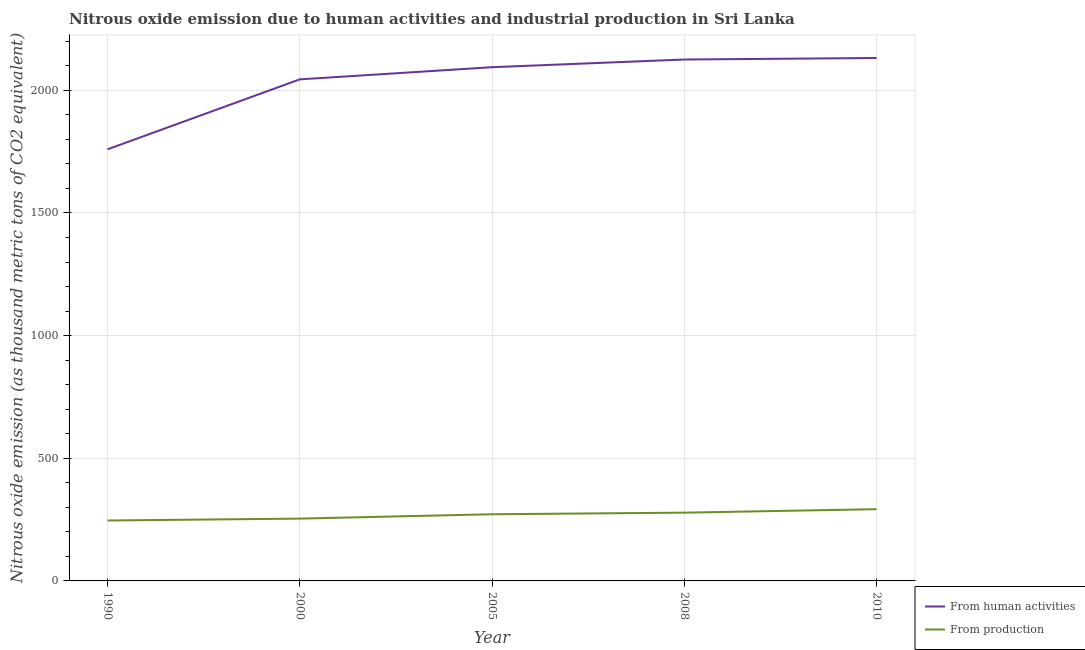Does the line corresponding to amount of emissions from human activities intersect with the line corresponding to amount of emissions generated from industries?
Give a very brief answer. No. What is the amount of emissions from human activities in 2010?
Your response must be concise. 2131.6. Across all years, what is the maximum amount of emissions generated from industries?
Keep it short and to the point. 292.4. Across all years, what is the minimum amount of emissions from human activities?
Keep it short and to the point. 1759.4. In which year was the amount of emissions generated from industries maximum?
Offer a terse response. 2010. In which year was the amount of emissions generated from industries minimum?
Your answer should be compact. 1990. What is the total amount of emissions from human activities in the graph?
Offer a very short reply. 1.02e+04. What is the difference between the amount of emissions from human activities in 1990 and that in 2005?
Your response must be concise. -334.7. What is the difference between the amount of emissions generated from industries in 2008 and the amount of emissions from human activities in 2005?
Provide a succinct answer. -1815.8. What is the average amount of emissions generated from industries per year?
Offer a terse response. 268.56. In the year 2005, what is the difference between the amount of emissions from human activities and amount of emissions generated from industries?
Ensure brevity in your answer.  1822.3. In how many years, is the amount of emissions from human activities greater than 1200 thousand metric tons?
Ensure brevity in your answer.  5. What is the ratio of the amount of emissions generated from industries in 2005 to that in 2010?
Your answer should be very brief. 0.93. Is the amount of emissions generated from industries in 2000 less than that in 2005?
Provide a short and direct response. Yes. What is the difference between the highest and the second highest amount of emissions from human activities?
Provide a short and direct response. 6.2. What is the difference between the highest and the lowest amount of emissions generated from industries?
Ensure brevity in your answer.  46.1. In how many years, is the amount of emissions from human activities greater than the average amount of emissions from human activities taken over all years?
Your response must be concise. 4. Is the sum of the amount of emissions from human activities in 1990 and 2010 greater than the maximum amount of emissions generated from industries across all years?
Provide a succinct answer. Yes. Does the amount of emissions from human activities monotonically increase over the years?
Provide a short and direct response. Yes. Is the amount of emissions from human activities strictly greater than the amount of emissions generated from industries over the years?
Your answer should be compact. Yes. Is the amount of emissions generated from industries strictly less than the amount of emissions from human activities over the years?
Offer a terse response. Yes. What is the difference between two consecutive major ticks on the Y-axis?
Provide a short and direct response. 500. Does the graph contain any zero values?
Your answer should be very brief. No. Where does the legend appear in the graph?
Your answer should be very brief. Bottom right. How are the legend labels stacked?
Give a very brief answer. Vertical. What is the title of the graph?
Offer a very short reply. Nitrous oxide emission due to human activities and industrial production in Sri Lanka. What is the label or title of the X-axis?
Your response must be concise. Year. What is the label or title of the Y-axis?
Make the answer very short. Nitrous oxide emission (as thousand metric tons of CO2 equivalent). What is the Nitrous oxide emission (as thousand metric tons of CO2 equivalent) in From human activities in 1990?
Provide a succinct answer. 1759.4. What is the Nitrous oxide emission (as thousand metric tons of CO2 equivalent) in From production in 1990?
Your answer should be very brief. 246.3. What is the Nitrous oxide emission (as thousand metric tons of CO2 equivalent) in From human activities in 2000?
Your response must be concise. 2044.5. What is the Nitrous oxide emission (as thousand metric tons of CO2 equivalent) in From production in 2000?
Your response must be concise. 254. What is the Nitrous oxide emission (as thousand metric tons of CO2 equivalent) of From human activities in 2005?
Your response must be concise. 2094.1. What is the Nitrous oxide emission (as thousand metric tons of CO2 equivalent) in From production in 2005?
Keep it short and to the point. 271.8. What is the Nitrous oxide emission (as thousand metric tons of CO2 equivalent) of From human activities in 2008?
Your response must be concise. 2125.4. What is the Nitrous oxide emission (as thousand metric tons of CO2 equivalent) in From production in 2008?
Provide a succinct answer. 278.3. What is the Nitrous oxide emission (as thousand metric tons of CO2 equivalent) of From human activities in 2010?
Provide a short and direct response. 2131.6. What is the Nitrous oxide emission (as thousand metric tons of CO2 equivalent) in From production in 2010?
Provide a short and direct response. 292.4. Across all years, what is the maximum Nitrous oxide emission (as thousand metric tons of CO2 equivalent) in From human activities?
Give a very brief answer. 2131.6. Across all years, what is the maximum Nitrous oxide emission (as thousand metric tons of CO2 equivalent) in From production?
Your response must be concise. 292.4. Across all years, what is the minimum Nitrous oxide emission (as thousand metric tons of CO2 equivalent) in From human activities?
Provide a succinct answer. 1759.4. Across all years, what is the minimum Nitrous oxide emission (as thousand metric tons of CO2 equivalent) of From production?
Offer a very short reply. 246.3. What is the total Nitrous oxide emission (as thousand metric tons of CO2 equivalent) of From human activities in the graph?
Your response must be concise. 1.02e+04. What is the total Nitrous oxide emission (as thousand metric tons of CO2 equivalent) of From production in the graph?
Offer a terse response. 1342.8. What is the difference between the Nitrous oxide emission (as thousand metric tons of CO2 equivalent) of From human activities in 1990 and that in 2000?
Ensure brevity in your answer.  -285.1. What is the difference between the Nitrous oxide emission (as thousand metric tons of CO2 equivalent) of From production in 1990 and that in 2000?
Ensure brevity in your answer.  -7.7. What is the difference between the Nitrous oxide emission (as thousand metric tons of CO2 equivalent) of From human activities in 1990 and that in 2005?
Provide a short and direct response. -334.7. What is the difference between the Nitrous oxide emission (as thousand metric tons of CO2 equivalent) of From production in 1990 and that in 2005?
Your answer should be very brief. -25.5. What is the difference between the Nitrous oxide emission (as thousand metric tons of CO2 equivalent) of From human activities in 1990 and that in 2008?
Give a very brief answer. -366. What is the difference between the Nitrous oxide emission (as thousand metric tons of CO2 equivalent) of From production in 1990 and that in 2008?
Provide a succinct answer. -32. What is the difference between the Nitrous oxide emission (as thousand metric tons of CO2 equivalent) of From human activities in 1990 and that in 2010?
Provide a succinct answer. -372.2. What is the difference between the Nitrous oxide emission (as thousand metric tons of CO2 equivalent) in From production in 1990 and that in 2010?
Offer a terse response. -46.1. What is the difference between the Nitrous oxide emission (as thousand metric tons of CO2 equivalent) of From human activities in 2000 and that in 2005?
Provide a short and direct response. -49.6. What is the difference between the Nitrous oxide emission (as thousand metric tons of CO2 equivalent) of From production in 2000 and that in 2005?
Offer a terse response. -17.8. What is the difference between the Nitrous oxide emission (as thousand metric tons of CO2 equivalent) of From human activities in 2000 and that in 2008?
Offer a terse response. -80.9. What is the difference between the Nitrous oxide emission (as thousand metric tons of CO2 equivalent) in From production in 2000 and that in 2008?
Your response must be concise. -24.3. What is the difference between the Nitrous oxide emission (as thousand metric tons of CO2 equivalent) in From human activities in 2000 and that in 2010?
Make the answer very short. -87.1. What is the difference between the Nitrous oxide emission (as thousand metric tons of CO2 equivalent) in From production in 2000 and that in 2010?
Offer a terse response. -38.4. What is the difference between the Nitrous oxide emission (as thousand metric tons of CO2 equivalent) of From human activities in 2005 and that in 2008?
Provide a succinct answer. -31.3. What is the difference between the Nitrous oxide emission (as thousand metric tons of CO2 equivalent) of From human activities in 2005 and that in 2010?
Keep it short and to the point. -37.5. What is the difference between the Nitrous oxide emission (as thousand metric tons of CO2 equivalent) in From production in 2005 and that in 2010?
Ensure brevity in your answer.  -20.6. What is the difference between the Nitrous oxide emission (as thousand metric tons of CO2 equivalent) of From production in 2008 and that in 2010?
Offer a very short reply. -14.1. What is the difference between the Nitrous oxide emission (as thousand metric tons of CO2 equivalent) of From human activities in 1990 and the Nitrous oxide emission (as thousand metric tons of CO2 equivalent) of From production in 2000?
Provide a short and direct response. 1505.4. What is the difference between the Nitrous oxide emission (as thousand metric tons of CO2 equivalent) of From human activities in 1990 and the Nitrous oxide emission (as thousand metric tons of CO2 equivalent) of From production in 2005?
Provide a succinct answer. 1487.6. What is the difference between the Nitrous oxide emission (as thousand metric tons of CO2 equivalent) in From human activities in 1990 and the Nitrous oxide emission (as thousand metric tons of CO2 equivalent) in From production in 2008?
Provide a succinct answer. 1481.1. What is the difference between the Nitrous oxide emission (as thousand metric tons of CO2 equivalent) of From human activities in 1990 and the Nitrous oxide emission (as thousand metric tons of CO2 equivalent) of From production in 2010?
Your answer should be compact. 1467. What is the difference between the Nitrous oxide emission (as thousand metric tons of CO2 equivalent) of From human activities in 2000 and the Nitrous oxide emission (as thousand metric tons of CO2 equivalent) of From production in 2005?
Provide a short and direct response. 1772.7. What is the difference between the Nitrous oxide emission (as thousand metric tons of CO2 equivalent) of From human activities in 2000 and the Nitrous oxide emission (as thousand metric tons of CO2 equivalent) of From production in 2008?
Give a very brief answer. 1766.2. What is the difference between the Nitrous oxide emission (as thousand metric tons of CO2 equivalent) of From human activities in 2000 and the Nitrous oxide emission (as thousand metric tons of CO2 equivalent) of From production in 2010?
Offer a very short reply. 1752.1. What is the difference between the Nitrous oxide emission (as thousand metric tons of CO2 equivalent) in From human activities in 2005 and the Nitrous oxide emission (as thousand metric tons of CO2 equivalent) in From production in 2008?
Provide a short and direct response. 1815.8. What is the difference between the Nitrous oxide emission (as thousand metric tons of CO2 equivalent) in From human activities in 2005 and the Nitrous oxide emission (as thousand metric tons of CO2 equivalent) in From production in 2010?
Your answer should be very brief. 1801.7. What is the difference between the Nitrous oxide emission (as thousand metric tons of CO2 equivalent) in From human activities in 2008 and the Nitrous oxide emission (as thousand metric tons of CO2 equivalent) in From production in 2010?
Your answer should be very brief. 1833. What is the average Nitrous oxide emission (as thousand metric tons of CO2 equivalent) of From human activities per year?
Make the answer very short. 2031. What is the average Nitrous oxide emission (as thousand metric tons of CO2 equivalent) in From production per year?
Offer a very short reply. 268.56. In the year 1990, what is the difference between the Nitrous oxide emission (as thousand metric tons of CO2 equivalent) of From human activities and Nitrous oxide emission (as thousand metric tons of CO2 equivalent) of From production?
Give a very brief answer. 1513.1. In the year 2000, what is the difference between the Nitrous oxide emission (as thousand metric tons of CO2 equivalent) in From human activities and Nitrous oxide emission (as thousand metric tons of CO2 equivalent) in From production?
Keep it short and to the point. 1790.5. In the year 2005, what is the difference between the Nitrous oxide emission (as thousand metric tons of CO2 equivalent) in From human activities and Nitrous oxide emission (as thousand metric tons of CO2 equivalent) in From production?
Keep it short and to the point. 1822.3. In the year 2008, what is the difference between the Nitrous oxide emission (as thousand metric tons of CO2 equivalent) in From human activities and Nitrous oxide emission (as thousand metric tons of CO2 equivalent) in From production?
Provide a short and direct response. 1847.1. In the year 2010, what is the difference between the Nitrous oxide emission (as thousand metric tons of CO2 equivalent) of From human activities and Nitrous oxide emission (as thousand metric tons of CO2 equivalent) of From production?
Make the answer very short. 1839.2. What is the ratio of the Nitrous oxide emission (as thousand metric tons of CO2 equivalent) of From human activities in 1990 to that in 2000?
Your answer should be compact. 0.86. What is the ratio of the Nitrous oxide emission (as thousand metric tons of CO2 equivalent) of From production in 1990 to that in 2000?
Keep it short and to the point. 0.97. What is the ratio of the Nitrous oxide emission (as thousand metric tons of CO2 equivalent) in From human activities in 1990 to that in 2005?
Your answer should be compact. 0.84. What is the ratio of the Nitrous oxide emission (as thousand metric tons of CO2 equivalent) of From production in 1990 to that in 2005?
Your response must be concise. 0.91. What is the ratio of the Nitrous oxide emission (as thousand metric tons of CO2 equivalent) in From human activities in 1990 to that in 2008?
Your answer should be compact. 0.83. What is the ratio of the Nitrous oxide emission (as thousand metric tons of CO2 equivalent) of From production in 1990 to that in 2008?
Your answer should be compact. 0.89. What is the ratio of the Nitrous oxide emission (as thousand metric tons of CO2 equivalent) in From human activities in 1990 to that in 2010?
Provide a succinct answer. 0.83. What is the ratio of the Nitrous oxide emission (as thousand metric tons of CO2 equivalent) of From production in 1990 to that in 2010?
Make the answer very short. 0.84. What is the ratio of the Nitrous oxide emission (as thousand metric tons of CO2 equivalent) in From human activities in 2000 to that in 2005?
Your response must be concise. 0.98. What is the ratio of the Nitrous oxide emission (as thousand metric tons of CO2 equivalent) in From production in 2000 to that in 2005?
Your answer should be very brief. 0.93. What is the ratio of the Nitrous oxide emission (as thousand metric tons of CO2 equivalent) of From human activities in 2000 to that in 2008?
Keep it short and to the point. 0.96. What is the ratio of the Nitrous oxide emission (as thousand metric tons of CO2 equivalent) of From production in 2000 to that in 2008?
Provide a short and direct response. 0.91. What is the ratio of the Nitrous oxide emission (as thousand metric tons of CO2 equivalent) in From human activities in 2000 to that in 2010?
Ensure brevity in your answer.  0.96. What is the ratio of the Nitrous oxide emission (as thousand metric tons of CO2 equivalent) of From production in 2000 to that in 2010?
Offer a terse response. 0.87. What is the ratio of the Nitrous oxide emission (as thousand metric tons of CO2 equivalent) of From production in 2005 to that in 2008?
Provide a succinct answer. 0.98. What is the ratio of the Nitrous oxide emission (as thousand metric tons of CO2 equivalent) of From human activities in 2005 to that in 2010?
Provide a short and direct response. 0.98. What is the ratio of the Nitrous oxide emission (as thousand metric tons of CO2 equivalent) in From production in 2005 to that in 2010?
Offer a very short reply. 0.93. What is the ratio of the Nitrous oxide emission (as thousand metric tons of CO2 equivalent) in From production in 2008 to that in 2010?
Your answer should be compact. 0.95. What is the difference between the highest and the second highest Nitrous oxide emission (as thousand metric tons of CO2 equivalent) in From production?
Your answer should be compact. 14.1. What is the difference between the highest and the lowest Nitrous oxide emission (as thousand metric tons of CO2 equivalent) of From human activities?
Your response must be concise. 372.2. What is the difference between the highest and the lowest Nitrous oxide emission (as thousand metric tons of CO2 equivalent) of From production?
Your response must be concise. 46.1. 